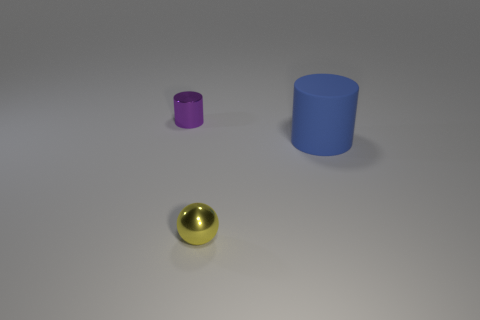Add 1 blue cylinders. How many objects exist? 4 Subtract 2 cylinders. How many cylinders are left? 0 Subtract all purple cylinders. How many cylinders are left? 1 Subtract all balls. How many objects are left? 2 Add 1 large blue cylinders. How many large blue cylinders are left? 2 Add 3 small objects. How many small objects exist? 5 Subtract 1 purple cylinders. How many objects are left? 2 Subtract all blue cylinders. Subtract all brown cubes. How many cylinders are left? 1 Subtract all yellow metal spheres. Subtract all small cyan things. How many objects are left? 2 